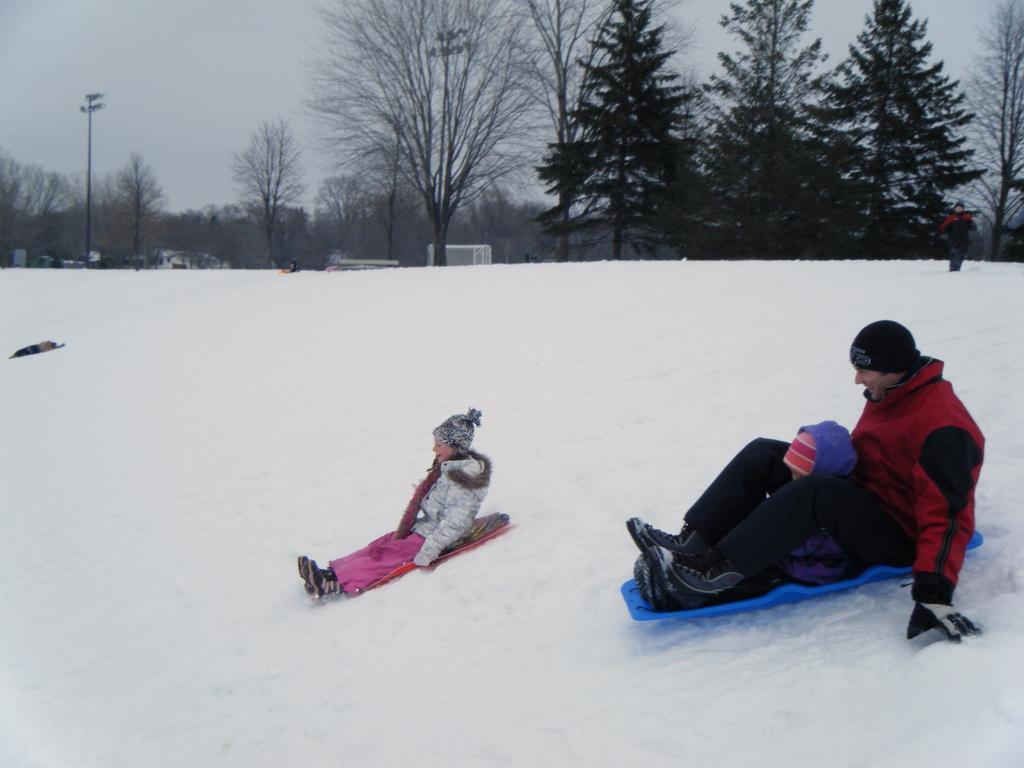How would you summarize this image in a sentence or two? In this picture we can see two persons are sitting on snowboards, at the bottom there is snow, we can see trees and a person in the background, there is the sky at the top of the picture. 